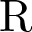<formula> <loc_0><loc_0><loc_500><loc_500>R</formula> 